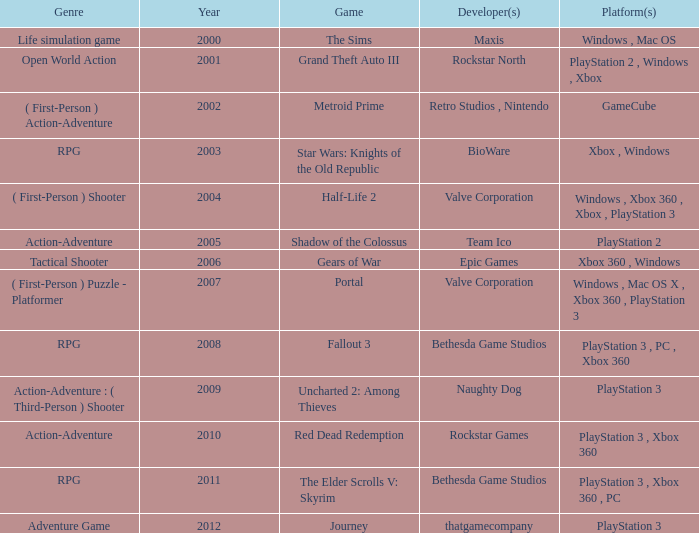What's the genre of The Sims before 2002? Life simulation game. 